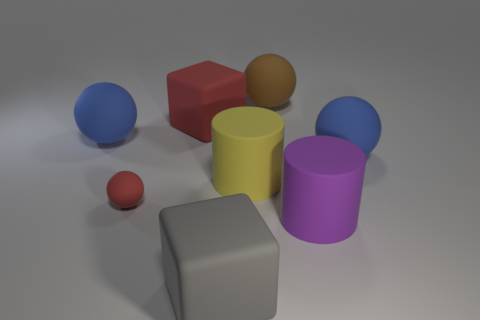Subtract 1 spheres. How many spheres are left? 3 Add 1 tiny cyan rubber objects. How many objects exist? 9 Subtract all yellow objects. Subtract all gray rubber blocks. How many objects are left? 6 Add 6 big gray things. How many big gray things are left? 7 Add 1 yellow matte balls. How many yellow matte balls exist? 1 Subtract 0 yellow blocks. How many objects are left? 8 